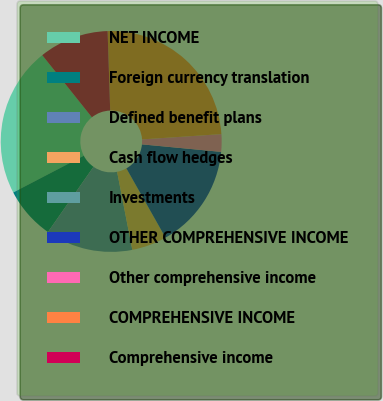<chart> <loc_0><loc_0><loc_500><loc_500><pie_chart><fcel>NET INCOME<fcel>Foreign currency translation<fcel>Defined benefit plans<fcel>Cash flow hedges<fcel>Investments<fcel>OTHER COMPREHENSIVE INCOME<fcel>Other comprehensive income<fcel>COMPREHENSIVE INCOME<fcel>Comprehensive income<nl><fcel>21.91%<fcel>7.66%<fcel>12.76%<fcel>5.11%<fcel>0.01%<fcel>15.31%<fcel>2.56%<fcel>24.46%<fcel>10.21%<nl></chart> 